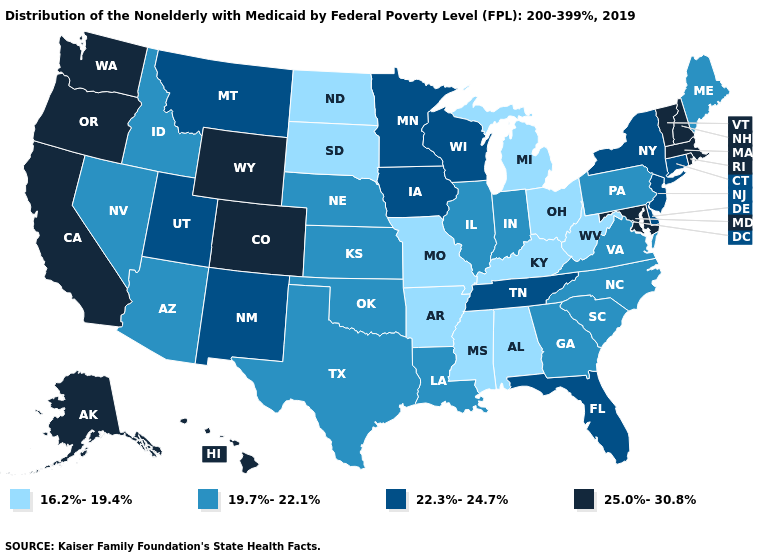Among the states that border Maryland , does Delaware have the highest value?
Short answer required. Yes. Which states have the lowest value in the West?
Keep it brief. Arizona, Idaho, Nevada. Which states have the lowest value in the USA?
Short answer required. Alabama, Arkansas, Kentucky, Michigan, Mississippi, Missouri, North Dakota, Ohio, South Dakota, West Virginia. What is the value of Montana?
Write a very short answer. 22.3%-24.7%. Is the legend a continuous bar?
Keep it brief. No. What is the value of Nebraska?
Short answer required. 19.7%-22.1%. Name the states that have a value in the range 25.0%-30.8%?
Keep it brief. Alaska, California, Colorado, Hawaii, Maryland, Massachusetts, New Hampshire, Oregon, Rhode Island, Vermont, Washington, Wyoming. What is the value of New York?
Be succinct. 22.3%-24.7%. What is the value of Ohio?
Keep it brief. 16.2%-19.4%. What is the highest value in the USA?
Concise answer only. 25.0%-30.8%. Name the states that have a value in the range 25.0%-30.8%?
Give a very brief answer. Alaska, California, Colorado, Hawaii, Maryland, Massachusetts, New Hampshire, Oregon, Rhode Island, Vermont, Washington, Wyoming. Which states have the highest value in the USA?
Quick response, please. Alaska, California, Colorado, Hawaii, Maryland, Massachusetts, New Hampshire, Oregon, Rhode Island, Vermont, Washington, Wyoming. Does the first symbol in the legend represent the smallest category?
Quick response, please. Yes. Among the states that border Texas , does New Mexico have the highest value?
Short answer required. Yes. Which states hav the highest value in the West?
Keep it brief. Alaska, California, Colorado, Hawaii, Oregon, Washington, Wyoming. 